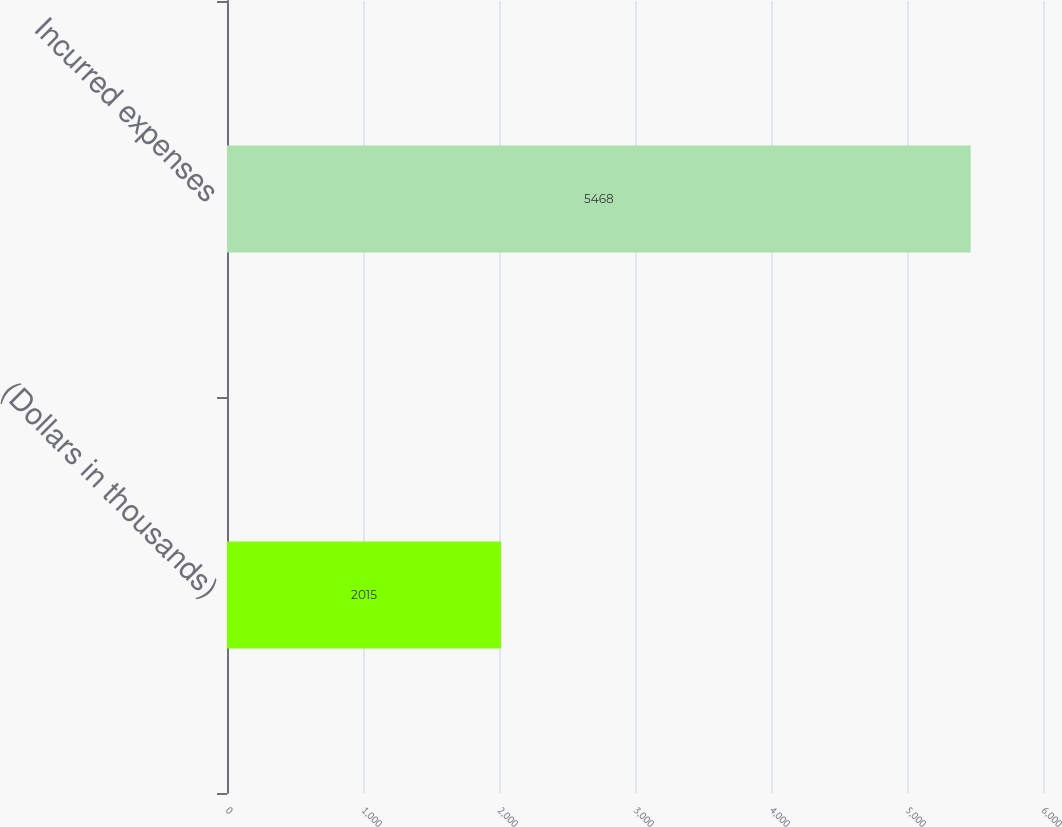<chart> <loc_0><loc_0><loc_500><loc_500><bar_chart><fcel>(Dollars in thousands)<fcel>Incurred expenses<nl><fcel>2015<fcel>5468<nl></chart> 